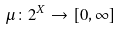Convert formula to latex. <formula><loc_0><loc_0><loc_500><loc_500>\mu \colon 2 ^ { X } \to [ 0 , \infty ]</formula> 